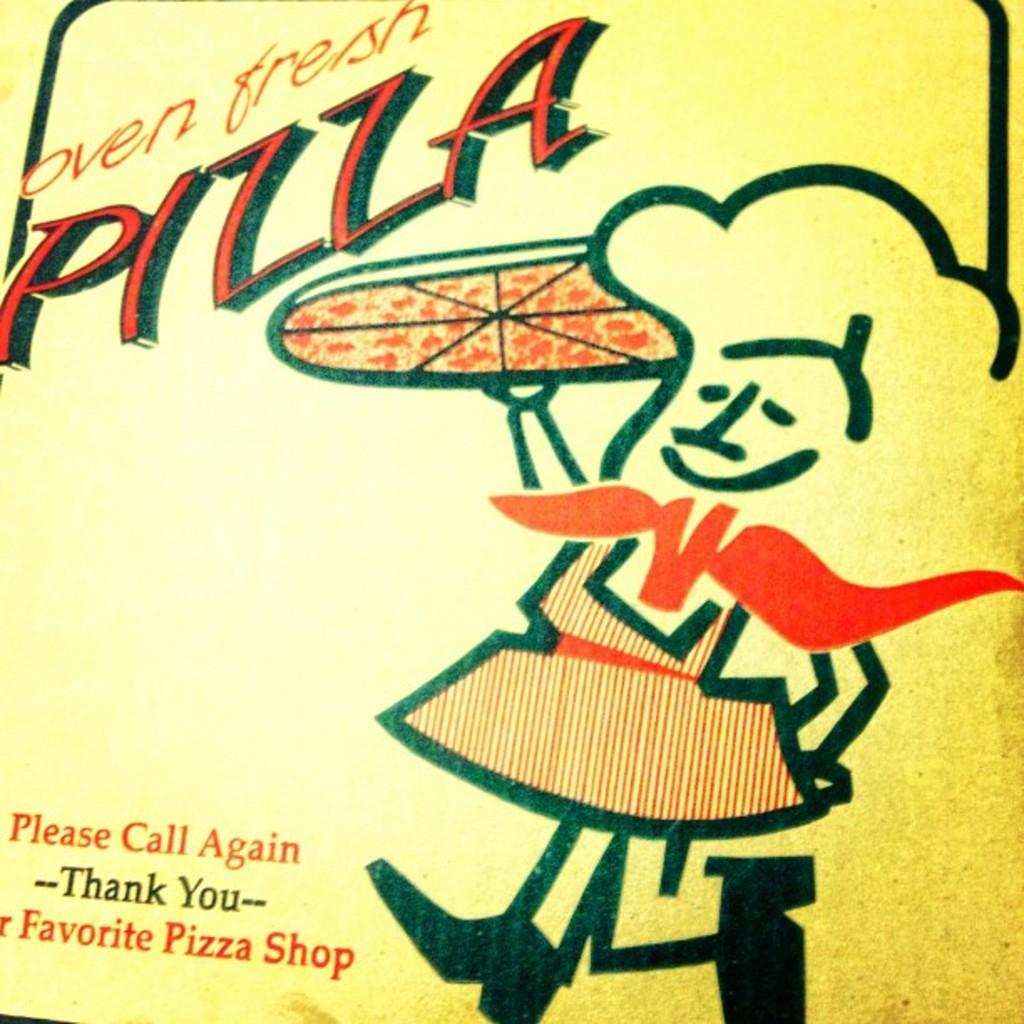<image>
Relay a brief, clear account of the picture shown. A box for Oven fresh pizza which gives a message to Please Call Again, Thank you. 